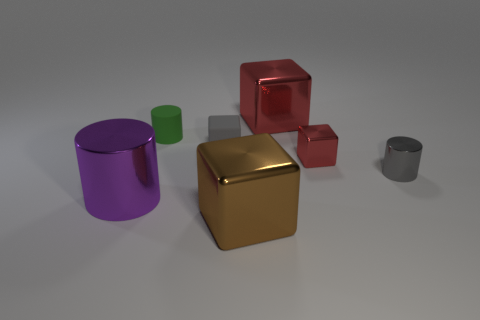Subtract all tiny cylinders. How many cylinders are left? 1 Subtract all green balls. How many red blocks are left? 2 Subtract 1 cylinders. How many cylinders are left? 2 Subtract all brown cubes. How many cubes are left? 3 Add 2 green rubber objects. How many objects exist? 9 Add 7 large green matte things. How many large green matte things exist? 7 Subtract 1 green cylinders. How many objects are left? 6 Subtract all blocks. How many objects are left? 3 Subtract all cyan cylinders. Subtract all red balls. How many cylinders are left? 3 Subtract all gray cubes. Subtract all big purple metal objects. How many objects are left? 5 